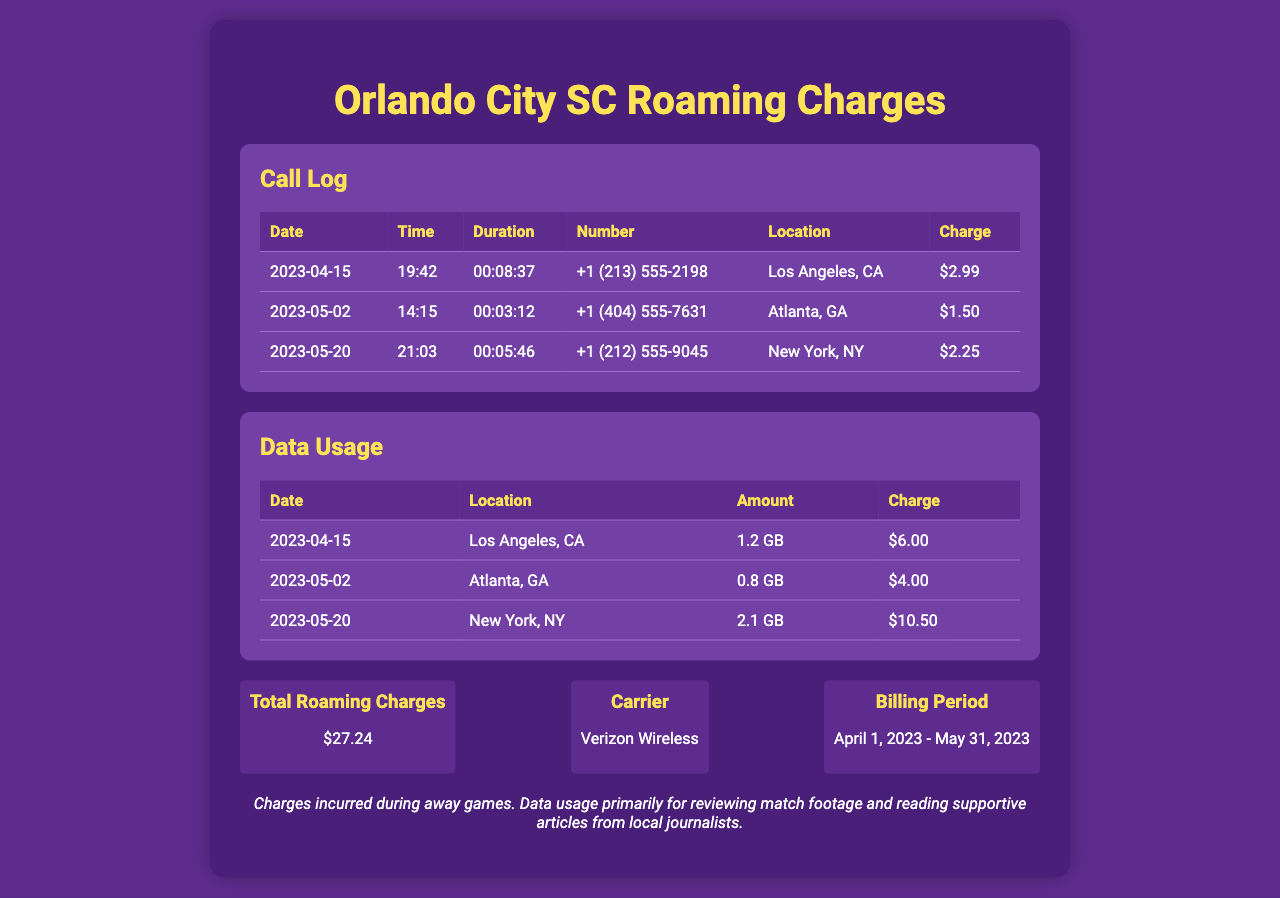what is the total roaming charge? The total roaming charge is explicitly listed in the summary section of the document.
Answer: $27.24 who is the carrier? The carrier is mentioned in the summary section as the service provider.
Answer: Verizon Wireless what is the maximum data usage recorded? The maximum data usage is identified by comparing the amounts listed in the data usage section.
Answer: 2.1 GB when was the call made to the number +1 (404) 555-7631? The date of the call can be found in the call log table.
Answer: 2023-05-02 which city had the highest charge for data usage? The city with the highest charge is determined by reviewing the charges listed in the data usage section.
Answer: New York, NY how many calls are recorded in the document? The number of calls can be counted from the entries in the call log table.
Answer: 3 what was the duration of the call made on 2023-04-15? The duration is recorded in the call log table against the specified date.
Answer: 00:08:37 which game location incurred the highest roaming charge? The game location with the highest charge can be identified from both call and data usage tables.
Answer: New York, NY 